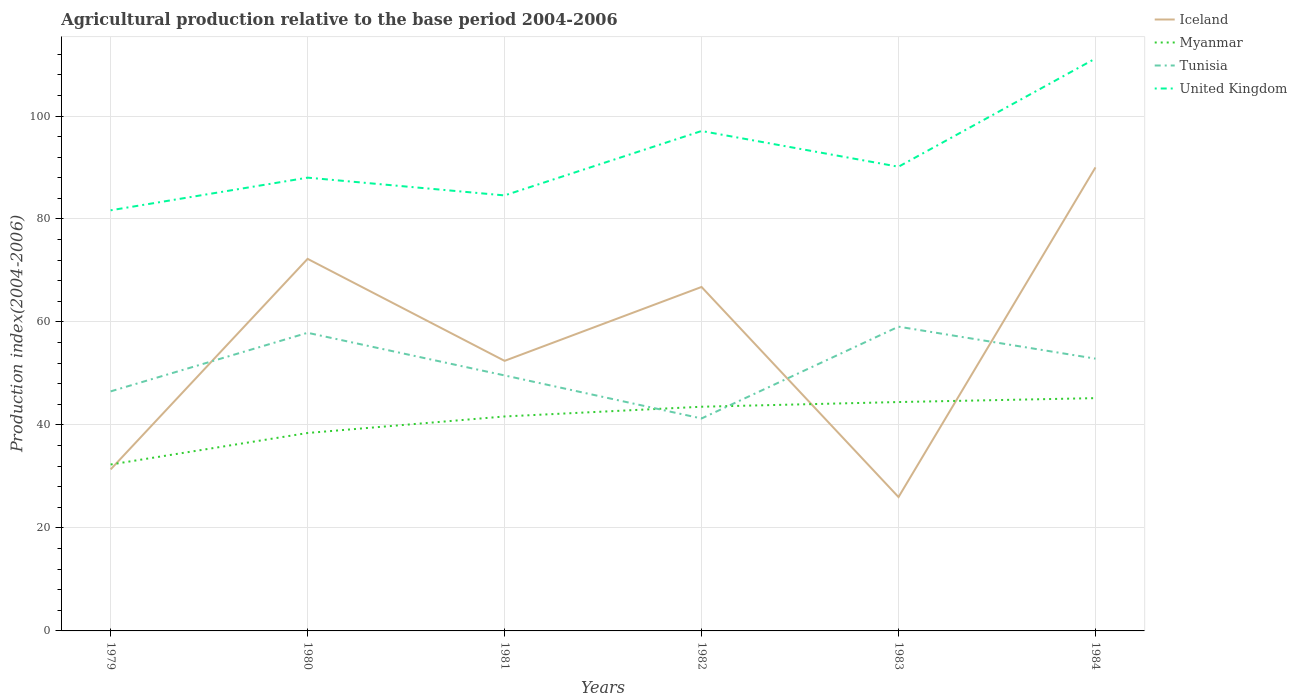How many different coloured lines are there?
Provide a short and direct response. 4. Does the line corresponding to Iceland intersect with the line corresponding to United Kingdom?
Ensure brevity in your answer.  No. Is the number of lines equal to the number of legend labels?
Your answer should be very brief. Yes. In which year was the agricultural production index in Iceland maximum?
Offer a very short reply. 1983. What is the total agricultural production index in Myanmar in the graph?
Provide a short and direct response. -6.01. What is the difference between the highest and the second highest agricultural production index in United Kingdom?
Your answer should be very brief. 29.48. What is the difference between the highest and the lowest agricultural production index in United Kingdom?
Ensure brevity in your answer.  2. Is the agricultural production index in Myanmar strictly greater than the agricultural production index in United Kingdom over the years?
Keep it short and to the point. Yes. How many lines are there?
Provide a succinct answer. 4. How many years are there in the graph?
Keep it short and to the point. 6. Are the values on the major ticks of Y-axis written in scientific E-notation?
Your answer should be compact. No. Does the graph contain any zero values?
Offer a terse response. No. How are the legend labels stacked?
Your answer should be compact. Vertical. What is the title of the graph?
Keep it short and to the point. Agricultural production relative to the base period 2004-2006. What is the label or title of the X-axis?
Give a very brief answer. Years. What is the label or title of the Y-axis?
Your response must be concise. Production index(2004-2006). What is the Production index(2004-2006) of Iceland in 1979?
Keep it short and to the point. 31.37. What is the Production index(2004-2006) of Myanmar in 1979?
Ensure brevity in your answer.  32.32. What is the Production index(2004-2006) in Tunisia in 1979?
Provide a succinct answer. 46.52. What is the Production index(2004-2006) of United Kingdom in 1979?
Provide a succinct answer. 81.69. What is the Production index(2004-2006) of Iceland in 1980?
Provide a succinct answer. 72.26. What is the Production index(2004-2006) of Myanmar in 1980?
Ensure brevity in your answer.  38.44. What is the Production index(2004-2006) in Tunisia in 1980?
Give a very brief answer. 57.9. What is the Production index(2004-2006) in United Kingdom in 1980?
Ensure brevity in your answer.  88.03. What is the Production index(2004-2006) of Iceland in 1981?
Ensure brevity in your answer.  52.45. What is the Production index(2004-2006) of Myanmar in 1981?
Give a very brief answer. 41.65. What is the Production index(2004-2006) in Tunisia in 1981?
Your response must be concise. 49.62. What is the Production index(2004-2006) of United Kingdom in 1981?
Provide a short and direct response. 84.58. What is the Production index(2004-2006) of Iceland in 1982?
Keep it short and to the point. 66.8. What is the Production index(2004-2006) of Myanmar in 1982?
Offer a very short reply. 43.54. What is the Production index(2004-2006) of Tunisia in 1982?
Keep it short and to the point. 41.26. What is the Production index(2004-2006) in United Kingdom in 1982?
Keep it short and to the point. 97.09. What is the Production index(2004-2006) in Myanmar in 1983?
Offer a terse response. 44.45. What is the Production index(2004-2006) in Tunisia in 1983?
Make the answer very short. 59.09. What is the Production index(2004-2006) in United Kingdom in 1983?
Keep it short and to the point. 90.15. What is the Production index(2004-2006) in Iceland in 1984?
Ensure brevity in your answer.  90.02. What is the Production index(2004-2006) of Myanmar in 1984?
Keep it short and to the point. 45.21. What is the Production index(2004-2006) in Tunisia in 1984?
Offer a terse response. 52.88. What is the Production index(2004-2006) in United Kingdom in 1984?
Your answer should be compact. 111.17. Across all years, what is the maximum Production index(2004-2006) in Iceland?
Provide a succinct answer. 90.02. Across all years, what is the maximum Production index(2004-2006) of Myanmar?
Your answer should be very brief. 45.21. Across all years, what is the maximum Production index(2004-2006) of Tunisia?
Offer a very short reply. 59.09. Across all years, what is the maximum Production index(2004-2006) in United Kingdom?
Make the answer very short. 111.17. Across all years, what is the minimum Production index(2004-2006) of Myanmar?
Give a very brief answer. 32.32. Across all years, what is the minimum Production index(2004-2006) in Tunisia?
Offer a terse response. 41.26. Across all years, what is the minimum Production index(2004-2006) of United Kingdom?
Your response must be concise. 81.69. What is the total Production index(2004-2006) of Iceland in the graph?
Offer a terse response. 338.9. What is the total Production index(2004-2006) in Myanmar in the graph?
Ensure brevity in your answer.  245.61. What is the total Production index(2004-2006) of Tunisia in the graph?
Your answer should be compact. 307.27. What is the total Production index(2004-2006) of United Kingdom in the graph?
Provide a succinct answer. 552.71. What is the difference between the Production index(2004-2006) of Iceland in 1979 and that in 1980?
Your answer should be compact. -40.89. What is the difference between the Production index(2004-2006) of Myanmar in 1979 and that in 1980?
Ensure brevity in your answer.  -6.12. What is the difference between the Production index(2004-2006) in Tunisia in 1979 and that in 1980?
Ensure brevity in your answer.  -11.38. What is the difference between the Production index(2004-2006) of United Kingdom in 1979 and that in 1980?
Your answer should be very brief. -6.34. What is the difference between the Production index(2004-2006) in Iceland in 1979 and that in 1981?
Offer a very short reply. -21.08. What is the difference between the Production index(2004-2006) in Myanmar in 1979 and that in 1981?
Make the answer very short. -9.33. What is the difference between the Production index(2004-2006) in Tunisia in 1979 and that in 1981?
Keep it short and to the point. -3.1. What is the difference between the Production index(2004-2006) of United Kingdom in 1979 and that in 1981?
Offer a terse response. -2.89. What is the difference between the Production index(2004-2006) of Iceland in 1979 and that in 1982?
Your answer should be compact. -35.43. What is the difference between the Production index(2004-2006) in Myanmar in 1979 and that in 1982?
Give a very brief answer. -11.22. What is the difference between the Production index(2004-2006) of Tunisia in 1979 and that in 1982?
Make the answer very short. 5.26. What is the difference between the Production index(2004-2006) in United Kingdom in 1979 and that in 1982?
Offer a very short reply. -15.4. What is the difference between the Production index(2004-2006) of Iceland in 1979 and that in 1983?
Your answer should be compact. 5.37. What is the difference between the Production index(2004-2006) of Myanmar in 1979 and that in 1983?
Your answer should be compact. -12.13. What is the difference between the Production index(2004-2006) in Tunisia in 1979 and that in 1983?
Provide a succinct answer. -12.57. What is the difference between the Production index(2004-2006) of United Kingdom in 1979 and that in 1983?
Keep it short and to the point. -8.46. What is the difference between the Production index(2004-2006) of Iceland in 1979 and that in 1984?
Give a very brief answer. -58.65. What is the difference between the Production index(2004-2006) in Myanmar in 1979 and that in 1984?
Your response must be concise. -12.89. What is the difference between the Production index(2004-2006) of Tunisia in 1979 and that in 1984?
Keep it short and to the point. -6.36. What is the difference between the Production index(2004-2006) of United Kingdom in 1979 and that in 1984?
Offer a very short reply. -29.48. What is the difference between the Production index(2004-2006) of Iceland in 1980 and that in 1981?
Your answer should be very brief. 19.81. What is the difference between the Production index(2004-2006) of Myanmar in 1980 and that in 1981?
Your answer should be very brief. -3.21. What is the difference between the Production index(2004-2006) of Tunisia in 1980 and that in 1981?
Your answer should be compact. 8.28. What is the difference between the Production index(2004-2006) of United Kingdom in 1980 and that in 1981?
Give a very brief answer. 3.45. What is the difference between the Production index(2004-2006) in Iceland in 1980 and that in 1982?
Offer a terse response. 5.46. What is the difference between the Production index(2004-2006) of Myanmar in 1980 and that in 1982?
Ensure brevity in your answer.  -5.1. What is the difference between the Production index(2004-2006) in Tunisia in 1980 and that in 1982?
Make the answer very short. 16.64. What is the difference between the Production index(2004-2006) of United Kingdom in 1980 and that in 1982?
Give a very brief answer. -9.06. What is the difference between the Production index(2004-2006) of Iceland in 1980 and that in 1983?
Provide a succinct answer. 46.26. What is the difference between the Production index(2004-2006) of Myanmar in 1980 and that in 1983?
Provide a short and direct response. -6.01. What is the difference between the Production index(2004-2006) in Tunisia in 1980 and that in 1983?
Offer a very short reply. -1.19. What is the difference between the Production index(2004-2006) of United Kingdom in 1980 and that in 1983?
Give a very brief answer. -2.12. What is the difference between the Production index(2004-2006) in Iceland in 1980 and that in 1984?
Your response must be concise. -17.76. What is the difference between the Production index(2004-2006) in Myanmar in 1980 and that in 1984?
Offer a terse response. -6.77. What is the difference between the Production index(2004-2006) of Tunisia in 1980 and that in 1984?
Your answer should be very brief. 5.02. What is the difference between the Production index(2004-2006) in United Kingdom in 1980 and that in 1984?
Your response must be concise. -23.14. What is the difference between the Production index(2004-2006) in Iceland in 1981 and that in 1982?
Provide a short and direct response. -14.35. What is the difference between the Production index(2004-2006) of Myanmar in 1981 and that in 1982?
Ensure brevity in your answer.  -1.89. What is the difference between the Production index(2004-2006) of Tunisia in 1981 and that in 1982?
Ensure brevity in your answer.  8.36. What is the difference between the Production index(2004-2006) in United Kingdom in 1981 and that in 1982?
Your response must be concise. -12.51. What is the difference between the Production index(2004-2006) in Iceland in 1981 and that in 1983?
Offer a terse response. 26.45. What is the difference between the Production index(2004-2006) in Myanmar in 1981 and that in 1983?
Ensure brevity in your answer.  -2.8. What is the difference between the Production index(2004-2006) of Tunisia in 1981 and that in 1983?
Provide a succinct answer. -9.47. What is the difference between the Production index(2004-2006) in United Kingdom in 1981 and that in 1983?
Keep it short and to the point. -5.57. What is the difference between the Production index(2004-2006) in Iceland in 1981 and that in 1984?
Your response must be concise. -37.57. What is the difference between the Production index(2004-2006) in Myanmar in 1981 and that in 1984?
Offer a terse response. -3.56. What is the difference between the Production index(2004-2006) of Tunisia in 1981 and that in 1984?
Your answer should be very brief. -3.26. What is the difference between the Production index(2004-2006) in United Kingdom in 1981 and that in 1984?
Give a very brief answer. -26.59. What is the difference between the Production index(2004-2006) of Iceland in 1982 and that in 1983?
Offer a very short reply. 40.8. What is the difference between the Production index(2004-2006) in Myanmar in 1982 and that in 1983?
Ensure brevity in your answer.  -0.91. What is the difference between the Production index(2004-2006) of Tunisia in 1982 and that in 1983?
Provide a succinct answer. -17.83. What is the difference between the Production index(2004-2006) in United Kingdom in 1982 and that in 1983?
Your answer should be compact. 6.94. What is the difference between the Production index(2004-2006) in Iceland in 1982 and that in 1984?
Your response must be concise. -23.22. What is the difference between the Production index(2004-2006) of Myanmar in 1982 and that in 1984?
Keep it short and to the point. -1.67. What is the difference between the Production index(2004-2006) in Tunisia in 1982 and that in 1984?
Give a very brief answer. -11.62. What is the difference between the Production index(2004-2006) of United Kingdom in 1982 and that in 1984?
Make the answer very short. -14.08. What is the difference between the Production index(2004-2006) in Iceland in 1983 and that in 1984?
Offer a terse response. -64.02. What is the difference between the Production index(2004-2006) in Myanmar in 1983 and that in 1984?
Give a very brief answer. -0.76. What is the difference between the Production index(2004-2006) in Tunisia in 1983 and that in 1984?
Your answer should be compact. 6.21. What is the difference between the Production index(2004-2006) in United Kingdom in 1983 and that in 1984?
Give a very brief answer. -21.02. What is the difference between the Production index(2004-2006) of Iceland in 1979 and the Production index(2004-2006) of Myanmar in 1980?
Your answer should be very brief. -7.07. What is the difference between the Production index(2004-2006) of Iceland in 1979 and the Production index(2004-2006) of Tunisia in 1980?
Provide a short and direct response. -26.53. What is the difference between the Production index(2004-2006) of Iceland in 1979 and the Production index(2004-2006) of United Kingdom in 1980?
Your answer should be very brief. -56.66. What is the difference between the Production index(2004-2006) in Myanmar in 1979 and the Production index(2004-2006) in Tunisia in 1980?
Keep it short and to the point. -25.58. What is the difference between the Production index(2004-2006) in Myanmar in 1979 and the Production index(2004-2006) in United Kingdom in 1980?
Make the answer very short. -55.71. What is the difference between the Production index(2004-2006) of Tunisia in 1979 and the Production index(2004-2006) of United Kingdom in 1980?
Provide a short and direct response. -41.51. What is the difference between the Production index(2004-2006) in Iceland in 1979 and the Production index(2004-2006) in Myanmar in 1981?
Keep it short and to the point. -10.28. What is the difference between the Production index(2004-2006) in Iceland in 1979 and the Production index(2004-2006) in Tunisia in 1981?
Your response must be concise. -18.25. What is the difference between the Production index(2004-2006) of Iceland in 1979 and the Production index(2004-2006) of United Kingdom in 1981?
Make the answer very short. -53.21. What is the difference between the Production index(2004-2006) of Myanmar in 1979 and the Production index(2004-2006) of Tunisia in 1981?
Make the answer very short. -17.3. What is the difference between the Production index(2004-2006) of Myanmar in 1979 and the Production index(2004-2006) of United Kingdom in 1981?
Your answer should be compact. -52.26. What is the difference between the Production index(2004-2006) of Tunisia in 1979 and the Production index(2004-2006) of United Kingdom in 1981?
Ensure brevity in your answer.  -38.06. What is the difference between the Production index(2004-2006) of Iceland in 1979 and the Production index(2004-2006) of Myanmar in 1982?
Give a very brief answer. -12.17. What is the difference between the Production index(2004-2006) of Iceland in 1979 and the Production index(2004-2006) of Tunisia in 1982?
Your answer should be compact. -9.89. What is the difference between the Production index(2004-2006) of Iceland in 1979 and the Production index(2004-2006) of United Kingdom in 1982?
Make the answer very short. -65.72. What is the difference between the Production index(2004-2006) of Myanmar in 1979 and the Production index(2004-2006) of Tunisia in 1982?
Your response must be concise. -8.94. What is the difference between the Production index(2004-2006) of Myanmar in 1979 and the Production index(2004-2006) of United Kingdom in 1982?
Your answer should be compact. -64.77. What is the difference between the Production index(2004-2006) in Tunisia in 1979 and the Production index(2004-2006) in United Kingdom in 1982?
Give a very brief answer. -50.57. What is the difference between the Production index(2004-2006) of Iceland in 1979 and the Production index(2004-2006) of Myanmar in 1983?
Offer a very short reply. -13.08. What is the difference between the Production index(2004-2006) in Iceland in 1979 and the Production index(2004-2006) in Tunisia in 1983?
Ensure brevity in your answer.  -27.72. What is the difference between the Production index(2004-2006) in Iceland in 1979 and the Production index(2004-2006) in United Kingdom in 1983?
Ensure brevity in your answer.  -58.78. What is the difference between the Production index(2004-2006) in Myanmar in 1979 and the Production index(2004-2006) in Tunisia in 1983?
Give a very brief answer. -26.77. What is the difference between the Production index(2004-2006) in Myanmar in 1979 and the Production index(2004-2006) in United Kingdom in 1983?
Make the answer very short. -57.83. What is the difference between the Production index(2004-2006) in Tunisia in 1979 and the Production index(2004-2006) in United Kingdom in 1983?
Provide a succinct answer. -43.63. What is the difference between the Production index(2004-2006) in Iceland in 1979 and the Production index(2004-2006) in Myanmar in 1984?
Provide a short and direct response. -13.84. What is the difference between the Production index(2004-2006) in Iceland in 1979 and the Production index(2004-2006) in Tunisia in 1984?
Offer a very short reply. -21.51. What is the difference between the Production index(2004-2006) of Iceland in 1979 and the Production index(2004-2006) of United Kingdom in 1984?
Your answer should be very brief. -79.8. What is the difference between the Production index(2004-2006) of Myanmar in 1979 and the Production index(2004-2006) of Tunisia in 1984?
Your response must be concise. -20.56. What is the difference between the Production index(2004-2006) in Myanmar in 1979 and the Production index(2004-2006) in United Kingdom in 1984?
Give a very brief answer. -78.85. What is the difference between the Production index(2004-2006) of Tunisia in 1979 and the Production index(2004-2006) of United Kingdom in 1984?
Your answer should be very brief. -64.65. What is the difference between the Production index(2004-2006) in Iceland in 1980 and the Production index(2004-2006) in Myanmar in 1981?
Provide a succinct answer. 30.61. What is the difference between the Production index(2004-2006) in Iceland in 1980 and the Production index(2004-2006) in Tunisia in 1981?
Offer a very short reply. 22.64. What is the difference between the Production index(2004-2006) of Iceland in 1980 and the Production index(2004-2006) of United Kingdom in 1981?
Give a very brief answer. -12.32. What is the difference between the Production index(2004-2006) of Myanmar in 1980 and the Production index(2004-2006) of Tunisia in 1981?
Provide a short and direct response. -11.18. What is the difference between the Production index(2004-2006) of Myanmar in 1980 and the Production index(2004-2006) of United Kingdom in 1981?
Offer a very short reply. -46.14. What is the difference between the Production index(2004-2006) in Tunisia in 1980 and the Production index(2004-2006) in United Kingdom in 1981?
Offer a very short reply. -26.68. What is the difference between the Production index(2004-2006) in Iceland in 1980 and the Production index(2004-2006) in Myanmar in 1982?
Give a very brief answer. 28.72. What is the difference between the Production index(2004-2006) in Iceland in 1980 and the Production index(2004-2006) in United Kingdom in 1982?
Provide a short and direct response. -24.83. What is the difference between the Production index(2004-2006) in Myanmar in 1980 and the Production index(2004-2006) in Tunisia in 1982?
Keep it short and to the point. -2.82. What is the difference between the Production index(2004-2006) in Myanmar in 1980 and the Production index(2004-2006) in United Kingdom in 1982?
Provide a succinct answer. -58.65. What is the difference between the Production index(2004-2006) of Tunisia in 1980 and the Production index(2004-2006) of United Kingdom in 1982?
Your answer should be compact. -39.19. What is the difference between the Production index(2004-2006) of Iceland in 1980 and the Production index(2004-2006) of Myanmar in 1983?
Offer a very short reply. 27.81. What is the difference between the Production index(2004-2006) of Iceland in 1980 and the Production index(2004-2006) of Tunisia in 1983?
Offer a very short reply. 13.17. What is the difference between the Production index(2004-2006) of Iceland in 1980 and the Production index(2004-2006) of United Kingdom in 1983?
Give a very brief answer. -17.89. What is the difference between the Production index(2004-2006) in Myanmar in 1980 and the Production index(2004-2006) in Tunisia in 1983?
Your answer should be compact. -20.65. What is the difference between the Production index(2004-2006) of Myanmar in 1980 and the Production index(2004-2006) of United Kingdom in 1983?
Your answer should be compact. -51.71. What is the difference between the Production index(2004-2006) of Tunisia in 1980 and the Production index(2004-2006) of United Kingdom in 1983?
Your response must be concise. -32.25. What is the difference between the Production index(2004-2006) of Iceland in 1980 and the Production index(2004-2006) of Myanmar in 1984?
Make the answer very short. 27.05. What is the difference between the Production index(2004-2006) in Iceland in 1980 and the Production index(2004-2006) in Tunisia in 1984?
Provide a succinct answer. 19.38. What is the difference between the Production index(2004-2006) of Iceland in 1980 and the Production index(2004-2006) of United Kingdom in 1984?
Offer a very short reply. -38.91. What is the difference between the Production index(2004-2006) of Myanmar in 1980 and the Production index(2004-2006) of Tunisia in 1984?
Offer a terse response. -14.44. What is the difference between the Production index(2004-2006) of Myanmar in 1980 and the Production index(2004-2006) of United Kingdom in 1984?
Give a very brief answer. -72.73. What is the difference between the Production index(2004-2006) in Tunisia in 1980 and the Production index(2004-2006) in United Kingdom in 1984?
Provide a succinct answer. -53.27. What is the difference between the Production index(2004-2006) in Iceland in 1981 and the Production index(2004-2006) in Myanmar in 1982?
Provide a succinct answer. 8.91. What is the difference between the Production index(2004-2006) of Iceland in 1981 and the Production index(2004-2006) of Tunisia in 1982?
Offer a very short reply. 11.19. What is the difference between the Production index(2004-2006) in Iceland in 1981 and the Production index(2004-2006) in United Kingdom in 1982?
Give a very brief answer. -44.64. What is the difference between the Production index(2004-2006) in Myanmar in 1981 and the Production index(2004-2006) in Tunisia in 1982?
Ensure brevity in your answer.  0.39. What is the difference between the Production index(2004-2006) of Myanmar in 1981 and the Production index(2004-2006) of United Kingdom in 1982?
Your answer should be very brief. -55.44. What is the difference between the Production index(2004-2006) of Tunisia in 1981 and the Production index(2004-2006) of United Kingdom in 1982?
Offer a very short reply. -47.47. What is the difference between the Production index(2004-2006) of Iceland in 1981 and the Production index(2004-2006) of Myanmar in 1983?
Keep it short and to the point. 8. What is the difference between the Production index(2004-2006) of Iceland in 1981 and the Production index(2004-2006) of Tunisia in 1983?
Your answer should be very brief. -6.64. What is the difference between the Production index(2004-2006) of Iceland in 1981 and the Production index(2004-2006) of United Kingdom in 1983?
Offer a very short reply. -37.7. What is the difference between the Production index(2004-2006) in Myanmar in 1981 and the Production index(2004-2006) in Tunisia in 1983?
Your answer should be very brief. -17.44. What is the difference between the Production index(2004-2006) of Myanmar in 1981 and the Production index(2004-2006) of United Kingdom in 1983?
Give a very brief answer. -48.5. What is the difference between the Production index(2004-2006) in Tunisia in 1981 and the Production index(2004-2006) in United Kingdom in 1983?
Keep it short and to the point. -40.53. What is the difference between the Production index(2004-2006) in Iceland in 1981 and the Production index(2004-2006) in Myanmar in 1984?
Keep it short and to the point. 7.24. What is the difference between the Production index(2004-2006) of Iceland in 1981 and the Production index(2004-2006) of Tunisia in 1984?
Offer a terse response. -0.43. What is the difference between the Production index(2004-2006) in Iceland in 1981 and the Production index(2004-2006) in United Kingdom in 1984?
Provide a short and direct response. -58.72. What is the difference between the Production index(2004-2006) of Myanmar in 1981 and the Production index(2004-2006) of Tunisia in 1984?
Provide a short and direct response. -11.23. What is the difference between the Production index(2004-2006) of Myanmar in 1981 and the Production index(2004-2006) of United Kingdom in 1984?
Your answer should be very brief. -69.52. What is the difference between the Production index(2004-2006) of Tunisia in 1981 and the Production index(2004-2006) of United Kingdom in 1984?
Provide a succinct answer. -61.55. What is the difference between the Production index(2004-2006) of Iceland in 1982 and the Production index(2004-2006) of Myanmar in 1983?
Provide a succinct answer. 22.35. What is the difference between the Production index(2004-2006) of Iceland in 1982 and the Production index(2004-2006) of Tunisia in 1983?
Offer a terse response. 7.71. What is the difference between the Production index(2004-2006) in Iceland in 1982 and the Production index(2004-2006) in United Kingdom in 1983?
Your answer should be compact. -23.35. What is the difference between the Production index(2004-2006) in Myanmar in 1982 and the Production index(2004-2006) in Tunisia in 1983?
Your response must be concise. -15.55. What is the difference between the Production index(2004-2006) of Myanmar in 1982 and the Production index(2004-2006) of United Kingdom in 1983?
Give a very brief answer. -46.61. What is the difference between the Production index(2004-2006) in Tunisia in 1982 and the Production index(2004-2006) in United Kingdom in 1983?
Your answer should be compact. -48.89. What is the difference between the Production index(2004-2006) of Iceland in 1982 and the Production index(2004-2006) of Myanmar in 1984?
Provide a succinct answer. 21.59. What is the difference between the Production index(2004-2006) of Iceland in 1982 and the Production index(2004-2006) of Tunisia in 1984?
Your response must be concise. 13.92. What is the difference between the Production index(2004-2006) of Iceland in 1982 and the Production index(2004-2006) of United Kingdom in 1984?
Ensure brevity in your answer.  -44.37. What is the difference between the Production index(2004-2006) of Myanmar in 1982 and the Production index(2004-2006) of Tunisia in 1984?
Your answer should be compact. -9.34. What is the difference between the Production index(2004-2006) in Myanmar in 1982 and the Production index(2004-2006) in United Kingdom in 1984?
Your answer should be compact. -67.63. What is the difference between the Production index(2004-2006) of Tunisia in 1982 and the Production index(2004-2006) of United Kingdom in 1984?
Your answer should be very brief. -69.91. What is the difference between the Production index(2004-2006) of Iceland in 1983 and the Production index(2004-2006) of Myanmar in 1984?
Your answer should be very brief. -19.21. What is the difference between the Production index(2004-2006) in Iceland in 1983 and the Production index(2004-2006) in Tunisia in 1984?
Offer a terse response. -26.88. What is the difference between the Production index(2004-2006) in Iceland in 1983 and the Production index(2004-2006) in United Kingdom in 1984?
Provide a succinct answer. -85.17. What is the difference between the Production index(2004-2006) in Myanmar in 1983 and the Production index(2004-2006) in Tunisia in 1984?
Your response must be concise. -8.43. What is the difference between the Production index(2004-2006) in Myanmar in 1983 and the Production index(2004-2006) in United Kingdom in 1984?
Provide a short and direct response. -66.72. What is the difference between the Production index(2004-2006) of Tunisia in 1983 and the Production index(2004-2006) of United Kingdom in 1984?
Your answer should be compact. -52.08. What is the average Production index(2004-2006) of Iceland per year?
Your response must be concise. 56.48. What is the average Production index(2004-2006) of Myanmar per year?
Provide a succinct answer. 40.94. What is the average Production index(2004-2006) of Tunisia per year?
Provide a short and direct response. 51.21. What is the average Production index(2004-2006) in United Kingdom per year?
Your answer should be very brief. 92.12. In the year 1979, what is the difference between the Production index(2004-2006) in Iceland and Production index(2004-2006) in Myanmar?
Keep it short and to the point. -0.95. In the year 1979, what is the difference between the Production index(2004-2006) in Iceland and Production index(2004-2006) in Tunisia?
Offer a very short reply. -15.15. In the year 1979, what is the difference between the Production index(2004-2006) in Iceland and Production index(2004-2006) in United Kingdom?
Keep it short and to the point. -50.32. In the year 1979, what is the difference between the Production index(2004-2006) in Myanmar and Production index(2004-2006) in Tunisia?
Give a very brief answer. -14.2. In the year 1979, what is the difference between the Production index(2004-2006) in Myanmar and Production index(2004-2006) in United Kingdom?
Ensure brevity in your answer.  -49.37. In the year 1979, what is the difference between the Production index(2004-2006) in Tunisia and Production index(2004-2006) in United Kingdom?
Provide a succinct answer. -35.17. In the year 1980, what is the difference between the Production index(2004-2006) of Iceland and Production index(2004-2006) of Myanmar?
Offer a terse response. 33.82. In the year 1980, what is the difference between the Production index(2004-2006) of Iceland and Production index(2004-2006) of Tunisia?
Your answer should be very brief. 14.36. In the year 1980, what is the difference between the Production index(2004-2006) of Iceland and Production index(2004-2006) of United Kingdom?
Your response must be concise. -15.77. In the year 1980, what is the difference between the Production index(2004-2006) of Myanmar and Production index(2004-2006) of Tunisia?
Provide a succinct answer. -19.46. In the year 1980, what is the difference between the Production index(2004-2006) in Myanmar and Production index(2004-2006) in United Kingdom?
Provide a succinct answer. -49.59. In the year 1980, what is the difference between the Production index(2004-2006) in Tunisia and Production index(2004-2006) in United Kingdom?
Keep it short and to the point. -30.13. In the year 1981, what is the difference between the Production index(2004-2006) in Iceland and Production index(2004-2006) in Myanmar?
Your response must be concise. 10.8. In the year 1981, what is the difference between the Production index(2004-2006) in Iceland and Production index(2004-2006) in Tunisia?
Give a very brief answer. 2.83. In the year 1981, what is the difference between the Production index(2004-2006) of Iceland and Production index(2004-2006) of United Kingdom?
Your answer should be very brief. -32.13. In the year 1981, what is the difference between the Production index(2004-2006) of Myanmar and Production index(2004-2006) of Tunisia?
Your response must be concise. -7.97. In the year 1981, what is the difference between the Production index(2004-2006) of Myanmar and Production index(2004-2006) of United Kingdom?
Offer a terse response. -42.93. In the year 1981, what is the difference between the Production index(2004-2006) of Tunisia and Production index(2004-2006) of United Kingdom?
Your response must be concise. -34.96. In the year 1982, what is the difference between the Production index(2004-2006) of Iceland and Production index(2004-2006) of Myanmar?
Ensure brevity in your answer.  23.26. In the year 1982, what is the difference between the Production index(2004-2006) of Iceland and Production index(2004-2006) of Tunisia?
Ensure brevity in your answer.  25.54. In the year 1982, what is the difference between the Production index(2004-2006) of Iceland and Production index(2004-2006) of United Kingdom?
Your answer should be very brief. -30.29. In the year 1982, what is the difference between the Production index(2004-2006) of Myanmar and Production index(2004-2006) of Tunisia?
Give a very brief answer. 2.28. In the year 1982, what is the difference between the Production index(2004-2006) of Myanmar and Production index(2004-2006) of United Kingdom?
Provide a short and direct response. -53.55. In the year 1982, what is the difference between the Production index(2004-2006) of Tunisia and Production index(2004-2006) of United Kingdom?
Provide a short and direct response. -55.83. In the year 1983, what is the difference between the Production index(2004-2006) of Iceland and Production index(2004-2006) of Myanmar?
Your answer should be very brief. -18.45. In the year 1983, what is the difference between the Production index(2004-2006) of Iceland and Production index(2004-2006) of Tunisia?
Provide a short and direct response. -33.09. In the year 1983, what is the difference between the Production index(2004-2006) in Iceland and Production index(2004-2006) in United Kingdom?
Offer a very short reply. -64.15. In the year 1983, what is the difference between the Production index(2004-2006) in Myanmar and Production index(2004-2006) in Tunisia?
Provide a succinct answer. -14.64. In the year 1983, what is the difference between the Production index(2004-2006) in Myanmar and Production index(2004-2006) in United Kingdom?
Offer a very short reply. -45.7. In the year 1983, what is the difference between the Production index(2004-2006) in Tunisia and Production index(2004-2006) in United Kingdom?
Keep it short and to the point. -31.06. In the year 1984, what is the difference between the Production index(2004-2006) of Iceland and Production index(2004-2006) of Myanmar?
Keep it short and to the point. 44.81. In the year 1984, what is the difference between the Production index(2004-2006) in Iceland and Production index(2004-2006) in Tunisia?
Your response must be concise. 37.14. In the year 1984, what is the difference between the Production index(2004-2006) in Iceland and Production index(2004-2006) in United Kingdom?
Offer a terse response. -21.15. In the year 1984, what is the difference between the Production index(2004-2006) of Myanmar and Production index(2004-2006) of Tunisia?
Your response must be concise. -7.67. In the year 1984, what is the difference between the Production index(2004-2006) of Myanmar and Production index(2004-2006) of United Kingdom?
Make the answer very short. -65.96. In the year 1984, what is the difference between the Production index(2004-2006) of Tunisia and Production index(2004-2006) of United Kingdom?
Your answer should be compact. -58.29. What is the ratio of the Production index(2004-2006) in Iceland in 1979 to that in 1980?
Keep it short and to the point. 0.43. What is the ratio of the Production index(2004-2006) of Myanmar in 1979 to that in 1980?
Keep it short and to the point. 0.84. What is the ratio of the Production index(2004-2006) of Tunisia in 1979 to that in 1980?
Offer a terse response. 0.8. What is the ratio of the Production index(2004-2006) of United Kingdom in 1979 to that in 1980?
Your response must be concise. 0.93. What is the ratio of the Production index(2004-2006) in Iceland in 1979 to that in 1981?
Your answer should be very brief. 0.6. What is the ratio of the Production index(2004-2006) of Myanmar in 1979 to that in 1981?
Your answer should be very brief. 0.78. What is the ratio of the Production index(2004-2006) of United Kingdom in 1979 to that in 1981?
Make the answer very short. 0.97. What is the ratio of the Production index(2004-2006) in Iceland in 1979 to that in 1982?
Keep it short and to the point. 0.47. What is the ratio of the Production index(2004-2006) of Myanmar in 1979 to that in 1982?
Ensure brevity in your answer.  0.74. What is the ratio of the Production index(2004-2006) in Tunisia in 1979 to that in 1982?
Provide a succinct answer. 1.13. What is the ratio of the Production index(2004-2006) of United Kingdom in 1979 to that in 1982?
Provide a short and direct response. 0.84. What is the ratio of the Production index(2004-2006) of Iceland in 1979 to that in 1983?
Offer a terse response. 1.21. What is the ratio of the Production index(2004-2006) of Myanmar in 1979 to that in 1983?
Your answer should be compact. 0.73. What is the ratio of the Production index(2004-2006) of Tunisia in 1979 to that in 1983?
Keep it short and to the point. 0.79. What is the ratio of the Production index(2004-2006) in United Kingdom in 1979 to that in 1983?
Your answer should be very brief. 0.91. What is the ratio of the Production index(2004-2006) of Iceland in 1979 to that in 1984?
Offer a terse response. 0.35. What is the ratio of the Production index(2004-2006) of Myanmar in 1979 to that in 1984?
Provide a succinct answer. 0.71. What is the ratio of the Production index(2004-2006) of Tunisia in 1979 to that in 1984?
Your response must be concise. 0.88. What is the ratio of the Production index(2004-2006) of United Kingdom in 1979 to that in 1984?
Keep it short and to the point. 0.73. What is the ratio of the Production index(2004-2006) of Iceland in 1980 to that in 1981?
Provide a succinct answer. 1.38. What is the ratio of the Production index(2004-2006) of Myanmar in 1980 to that in 1981?
Provide a succinct answer. 0.92. What is the ratio of the Production index(2004-2006) in Tunisia in 1980 to that in 1981?
Your answer should be very brief. 1.17. What is the ratio of the Production index(2004-2006) in United Kingdom in 1980 to that in 1981?
Your answer should be very brief. 1.04. What is the ratio of the Production index(2004-2006) of Iceland in 1980 to that in 1982?
Ensure brevity in your answer.  1.08. What is the ratio of the Production index(2004-2006) in Myanmar in 1980 to that in 1982?
Give a very brief answer. 0.88. What is the ratio of the Production index(2004-2006) in Tunisia in 1980 to that in 1982?
Offer a very short reply. 1.4. What is the ratio of the Production index(2004-2006) of United Kingdom in 1980 to that in 1982?
Your answer should be compact. 0.91. What is the ratio of the Production index(2004-2006) of Iceland in 1980 to that in 1983?
Your answer should be compact. 2.78. What is the ratio of the Production index(2004-2006) of Myanmar in 1980 to that in 1983?
Keep it short and to the point. 0.86. What is the ratio of the Production index(2004-2006) in Tunisia in 1980 to that in 1983?
Your answer should be very brief. 0.98. What is the ratio of the Production index(2004-2006) of United Kingdom in 1980 to that in 1983?
Your response must be concise. 0.98. What is the ratio of the Production index(2004-2006) in Iceland in 1980 to that in 1984?
Your answer should be compact. 0.8. What is the ratio of the Production index(2004-2006) of Myanmar in 1980 to that in 1984?
Give a very brief answer. 0.85. What is the ratio of the Production index(2004-2006) of Tunisia in 1980 to that in 1984?
Provide a succinct answer. 1.09. What is the ratio of the Production index(2004-2006) of United Kingdom in 1980 to that in 1984?
Your answer should be very brief. 0.79. What is the ratio of the Production index(2004-2006) of Iceland in 1981 to that in 1982?
Your answer should be very brief. 0.79. What is the ratio of the Production index(2004-2006) in Myanmar in 1981 to that in 1982?
Your response must be concise. 0.96. What is the ratio of the Production index(2004-2006) of Tunisia in 1981 to that in 1982?
Your answer should be very brief. 1.2. What is the ratio of the Production index(2004-2006) in United Kingdom in 1981 to that in 1982?
Your answer should be very brief. 0.87. What is the ratio of the Production index(2004-2006) of Iceland in 1981 to that in 1983?
Your answer should be very brief. 2.02. What is the ratio of the Production index(2004-2006) of Myanmar in 1981 to that in 1983?
Make the answer very short. 0.94. What is the ratio of the Production index(2004-2006) in Tunisia in 1981 to that in 1983?
Give a very brief answer. 0.84. What is the ratio of the Production index(2004-2006) of United Kingdom in 1981 to that in 1983?
Ensure brevity in your answer.  0.94. What is the ratio of the Production index(2004-2006) of Iceland in 1981 to that in 1984?
Provide a short and direct response. 0.58. What is the ratio of the Production index(2004-2006) of Myanmar in 1981 to that in 1984?
Offer a very short reply. 0.92. What is the ratio of the Production index(2004-2006) of Tunisia in 1981 to that in 1984?
Your answer should be compact. 0.94. What is the ratio of the Production index(2004-2006) of United Kingdom in 1981 to that in 1984?
Your answer should be compact. 0.76. What is the ratio of the Production index(2004-2006) in Iceland in 1982 to that in 1983?
Make the answer very short. 2.57. What is the ratio of the Production index(2004-2006) of Myanmar in 1982 to that in 1983?
Provide a short and direct response. 0.98. What is the ratio of the Production index(2004-2006) in Tunisia in 1982 to that in 1983?
Provide a short and direct response. 0.7. What is the ratio of the Production index(2004-2006) of United Kingdom in 1982 to that in 1983?
Provide a short and direct response. 1.08. What is the ratio of the Production index(2004-2006) in Iceland in 1982 to that in 1984?
Your response must be concise. 0.74. What is the ratio of the Production index(2004-2006) in Myanmar in 1982 to that in 1984?
Your answer should be compact. 0.96. What is the ratio of the Production index(2004-2006) of Tunisia in 1982 to that in 1984?
Offer a terse response. 0.78. What is the ratio of the Production index(2004-2006) of United Kingdom in 1982 to that in 1984?
Your response must be concise. 0.87. What is the ratio of the Production index(2004-2006) in Iceland in 1983 to that in 1984?
Keep it short and to the point. 0.29. What is the ratio of the Production index(2004-2006) in Myanmar in 1983 to that in 1984?
Make the answer very short. 0.98. What is the ratio of the Production index(2004-2006) in Tunisia in 1983 to that in 1984?
Your answer should be very brief. 1.12. What is the ratio of the Production index(2004-2006) in United Kingdom in 1983 to that in 1984?
Provide a short and direct response. 0.81. What is the difference between the highest and the second highest Production index(2004-2006) in Iceland?
Your response must be concise. 17.76. What is the difference between the highest and the second highest Production index(2004-2006) in Myanmar?
Offer a very short reply. 0.76. What is the difference between the highest and the second highest Production index(2004-2006) in Tunisia?
Offer a terse response. 1.19. What is the difference between the highest and the second highest Production index(2004-2006) of United Kingdom?
Ensure brevity in your answer.  14.08. What is the difference between the highest and the lowest Production index(2004-2006) in Iceland?
Provide a short and direct response. 64.02. What is the difference between the highest and the lowest Production index(2004-2006) in Myanmar?
Your answer should be compact. 12.89. What is the difference between the highest and the lowest Production index(2004-2006) in Tunisia?
Your answer should be compact. 17.83. What is the difference between the highest and the lowest Production index(2004-2006) in United Kingdom?
Provide a succinct answer. 29.48. 